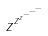<formula> <loc_0><loc_0><loc_500><loc_500>z ^ { z ^ { z ^ { - ^ { - ^ { - } } } } }</formula> 